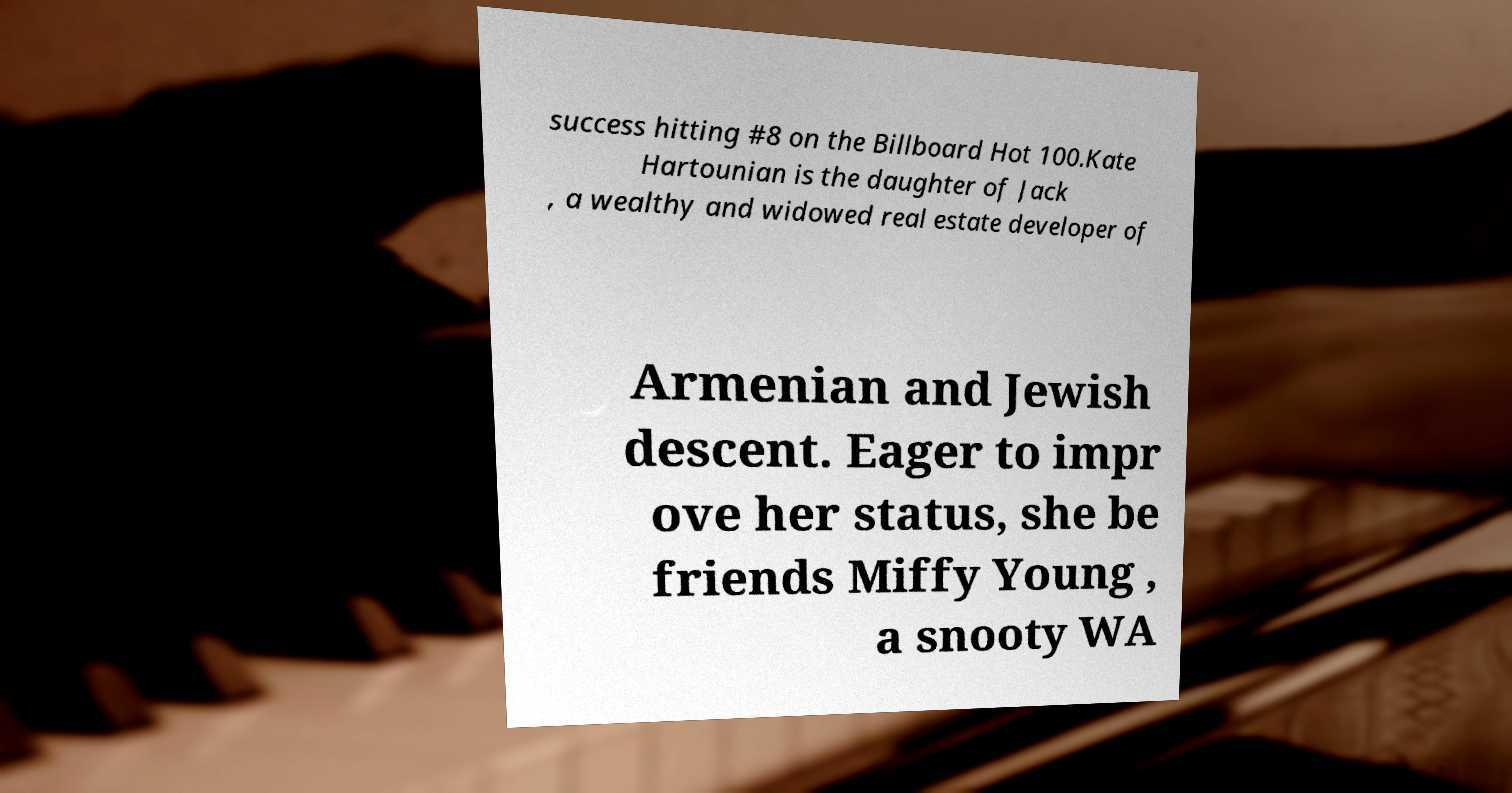Please read and relay the text visible in this image. What does it say? success hitting #8 on the Billboard Hot 100.Kate Hartounian is the daughter of Jack , a wealthy and widowed real estate developer of Armenian and Jewish descent. Eager to impr ove her status, she be friends Miffy Young , a snooty WA 